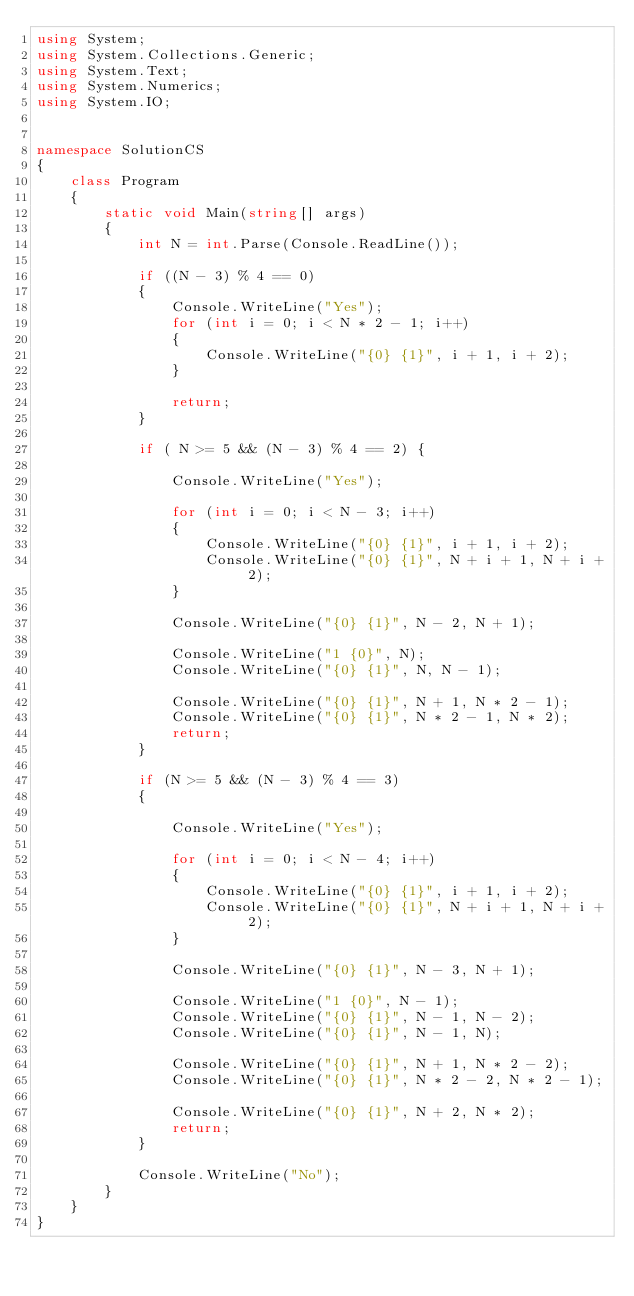Convert code to text. <code><loc_0><loc_0><loc_500><loc_500><_C#_>using System;
using System.Collections.Generic;
using System.Text;
using System.Numerics;
using System.IO;


namespace SolutionCS
{
    class Program
    {
        static void Main(string[] args)
        {
            int N = int.Parse(Console.ReadLine());

            if ((N - 3) % 4 == 0)
            {
                Console.WriteLine("Yes");
                for (int i = 0; i < N * 2 - 1; i++)
                {
                    Console.WriteLine("{0} {1}", i + 1, i + 2);
                }

                return;
            }

            if ( N >= 5 && (N - 3) % 4 == 2) { 

                Console.WriteLine("Yes");

                for (int i = 0; i < N - 3; i++)
                {
                    Console.WriteLine("{0} {1}", i + 1, i + 2);
                    Console.WriteLine("{0} {1}", N + i + 1, N + i + 2);
                }

                Console.WriteLine("{0} {1}", N - 2, N + 1);

                Console.WriteLine("1 {0}", N);
                Console.WriteLine("{0} {1}", N, N - 1);

                Console.WriteLine("{0} {1}", N + 1, N * 2 - 1);
                Console.WriteLine("{0} {1}", N * 2 - 1, N * 2);
                return;
            }

            if (N >= 5 && (N - 3) % 4 == 3)
            {

                Console.WriteLine("Yes");

                for (int i = 0; i < N - 4; i++)
                {
                    Console.WriteLine("{0} {1}", i + 1, i + 2);
                    Console.WriteLine("{0} {1}", N + i + 1, N + i + 2);
                }

                Console.WriteLine("{0} {1}", N - 3, N + 1);

                Console.WriteLine("1 {0}", N - 1);
                Console.WriteLine("{0} {1}", N - 1, N - 2);
                Console.WriteLine("{0} {1}", N - 1, N);

                Console.WriteLine("{0} {1}", N + 1, N * 2 - 2);
                Console.WriteLine("{0} {1}", N * 2 - 2, N * 2 - 1);

                Console.WriteLine("{0} {1}", N + 2, N * 2);
                return;
            }

            Console.WriteLine("No");
        }
    }
}
</code> 